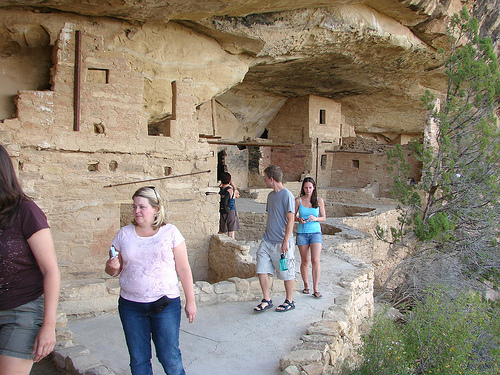<image>
Is the wall to the right of the woman? Yes. From this viewpoint, the wall is positioned to the right side relative to the woman. Is there a woman in front of the woman? Yes. The woman is positioned in front of the woman, appearing closer to the camera viewpoint. 